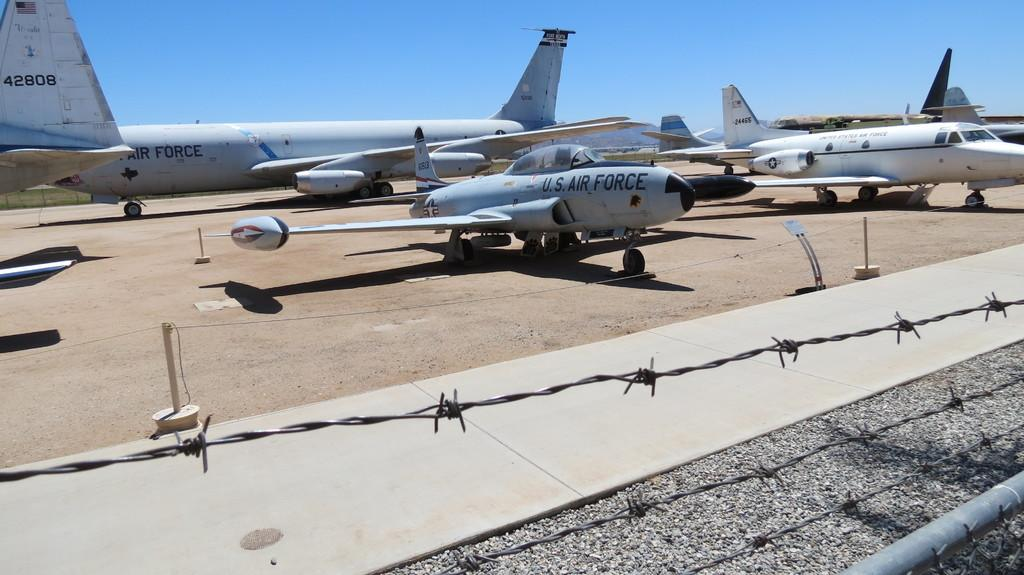<image>
Describe the image concisely. US Air Force planes sitting on the ground 